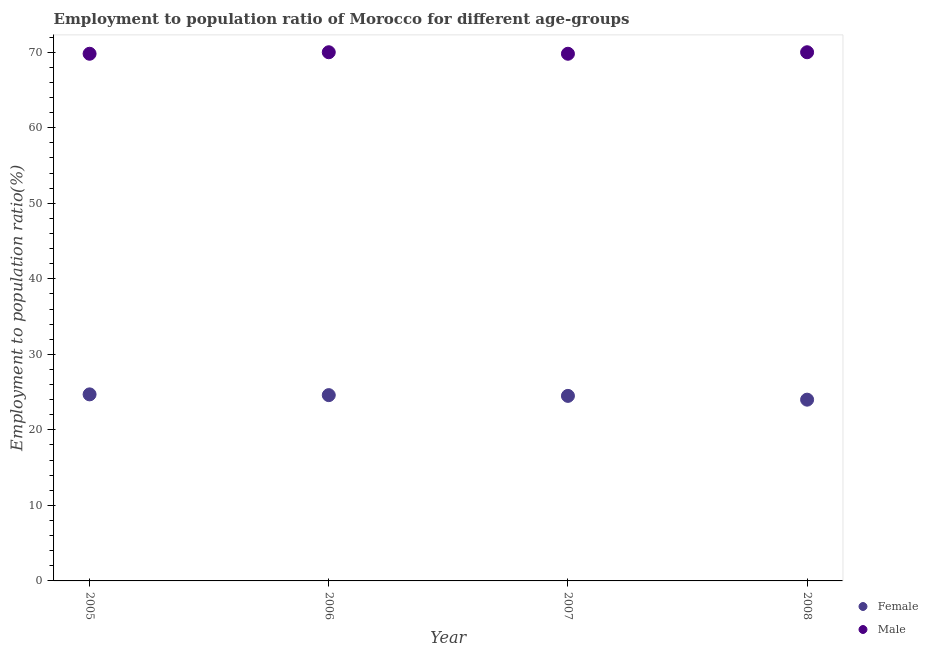Across all years, what is the maximum employment to population ratio(female)?
Offer a very short reply. 24.7. In which year was the employment to population ratio(male) maximum?
Ensure brevity in your answer.  2006. What is the total employment to population ratio(male) in the graph?
Provide a short and direct response. 279.6. What is the difference between the employment to population ratio(female) in 2007 and the employment to population ratio(male) in 2005?
Provide a short and direct response. -45.3. What is the average employment to population ratio(female) per year?
Offer a very short reply. 24.45. In the year 2006, what is the difference between the employment to population ratio(female) and employment to population ratio(male)?
Give a very brief answer. -45.4. What is the ratio of the employment to population ratio(female) in 2005 to that in 2008?
Offer a very short reply. 1.03. Is the employment to population ratio(male) in 2005 less than that in 2007?
Give a very brief answer. No. What is the difference between the highest and the second highest employment to population ratio(female)?
Your response must be concise. 0.1. What is the difference between the highest and the lowest employment to population ratio(female)?
Give a very brief answer. 0.7. Is the employment to population ratio(male) strictly less than the employment to population ratio(female) over the years?
Give a very brief answer. No. How many years are there in the graph?
Offer a very short reply. 4. What is the difference between two consecutive major ticks on the Y-axis?
Keep it short and to the point. 10. Does the graph contain any zero values?
Your answer should be very brief. No. Where does the legend appear in the graph?
Give a very brief answer. Bottom right. What is the title of the graph?
Your answer should be very brief. Employment to population ratio of Morocco for different age-groups. What is the Employment to population ratio(%) in Female in 2005?
Ensure brevity in your answer.  24.7. What is the Employment to population ratio(%) of Male in 2005?
Offer a very short reply. 69.8. What is the Employment to population ratio(%) of Female in 2006?
Provide a succinct answer. 24.6. What is the Employment to population ratio(%) of Male in 2006?
Offer a very short reply. 70. What is the Employment to population ratio(%) in Male in 2007?
Offer a very short reply. 69.8. What is the Employment to population ratio(%) in Male in 2008?
Give a very brief answer. 70. Across all years, what is the maximum Employment to population ratio(%) in Female?
Ensure brevity in your answer.  24.7. Across all years, what is the minimum Employment to population ratio(%) of Female?
Keep it short and to the point. 24. Across all years, what is the minimum Employment to population ratio(%) of Male?
Keep it short and to the point. 69.8. What is the total Employment to population ratio(%) in Female in the graph?
Provide a short and direct response. 97.8. What is the total Employment to population ratio(%) in Male in the graph?
Give a very brief answer. 279.6. What is the difference between the Employment to population ratio(%) of Female in 2005 and that in 2006?
Make the answer very short. 0.1. What is the difference between the Employment to population ratio(%) of Male in 2005 and that in 2006?
Your response must be concise. -0.2. What is the difference between the Employment to population ratio(%) of Female in 2005 and that in 2008?
Give a very brief answer. 0.7. What is the difference between the Employment to population ratio(%) in Female in 2006 and that in 2007?
Give a very brief answer. 0.1. What is the difference between the Employment to population ratio(%) of Male in 2006 and that in 2007?
Offer a very short reply. 0.2. What is the difference between the Employment to population ratio(%) of Female in 2006 and that in 2008?
Offer a terse response. 0.6. What is the difference between the Employment to population ratio(%) in Male in 2006 and that in 2008?
Your answer should be very brief. 0. What is the difference between the Employment to population ratio(%) in Male in 2007 and that in 2008?
Give a very brief answer. -0.2. What is the difference between the Employment to population ratio(%) of Female in 2005 and the Employment to population ratio(%) of Male in 2006?
Make the answer very short. -45.3. What is the difference between the Employment to population ratio(%) in Female in 2005 and the Employment to population ratio(%) in Male in 2007?
Give a very brief answer. -45.1. What is the difference between the Employment to population ratio(%) in Female in 2005 and the Employment to population ratio(%) in Male in 2008?
Your response must be concise. -45.3. What is the difference between the Employment to population ratio(%) in Female in 2006 and the Employment to population ratio(%) in Male in 2007?
Offer a very short reply. -45.2. What is the difference between the Employment to population ratio(%) of Female in 2006 and the Employment to population ratio(%) of Male in 2008?
Offer a terse response. -45.4. What is the difference between the Employment to population ratio(%) in Female in 2007 and the Employment to population ratio(%) in Male in 2008?
Your answer should be compact. -45.5. What is the average Employment to population ratio(%) of Female per year?
Offer a very short reply. 24.45. What is the average Employment to population ratio(%) in Male per year?
Your answer should be compact. 69.9. In the year 2005, what is the difference between the Employment to population ratio(%) of Female and Employment to population ratio(%) of Male?
Your response must be concise. -45.1. In the year 2006, what is the difference between the Employment to population ratio(%) in Female and Employment to population ratio(%) in Male?
Give a very brief answer. -45.4. In the year 2007, what is the difference between the Employment to population ratio(%) of Female and Employment to population ratio(%) of Male?
Ensure brevity in your answer.  -45.3. In the year 2008, what is the difference between the Employment to population ratio(%) in Female and Employment to population ratio(%) in Male?
Provide a short and direct response. -46. What is the ratio of the Employment to population ratio(%) of Male in 2005 to that in 2006?
Your answer should be compact. 1. What is the ratio of the Employment to population ratio(%) in Female in 2005 to that in 2007?
Provide a short and direct response. 1.01. What is the ratio of the Employment to population ratio(%) in Female in 2005 to that in 2008?
Keep it short and to the point. 1.03. What is the ratio of the Employment to population ratio(%) in Male in 2005 to that in 2008?
Give a very brief answer. 1. What is the ratio of the Employment to population ratio(%) of Female in 2006 to that in 2007?
Ensure brevity in your answer.  1. What is the ratio of the Employment to population ratio(%) in Male in 2006 to that in 2008?
Offer a very short reply. 1. What is the ratio of the Employment to population ratio(%) in Female in 2007 to that in 2008?
Provide a succinct answer. 1.02. What is the ratio of the Employment to population ratio(%) of Male in 2007 to that in 2008?
Your response must be concise. 1. What is the difference between the highest and the second highest Employment to population ratio(%) of Male?
Keep it short and to the point. 0. What is the difference between the highest and the lowest Employment to population ratio(%) in Female?
Provide a short and direct response. 0.7. What is the difference between the highest and the lowest Employment to population ratio(%) in Male?
Provide a short and direct response. 0.2. 